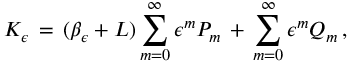<formula> <loc_0><loc_0><loc_500><loc_500>K _ { \epsilon } \, = \, ( \beta _ { \epsilon } + L ) \sum _ { m = 0 } ^ { \infty } \epsilon ^ { m } P _ { m } \, + \, \sum _ { m = 0 } ^ { \infty } \epsilon ^ { m } Q _ { m } \, ,</formula> 